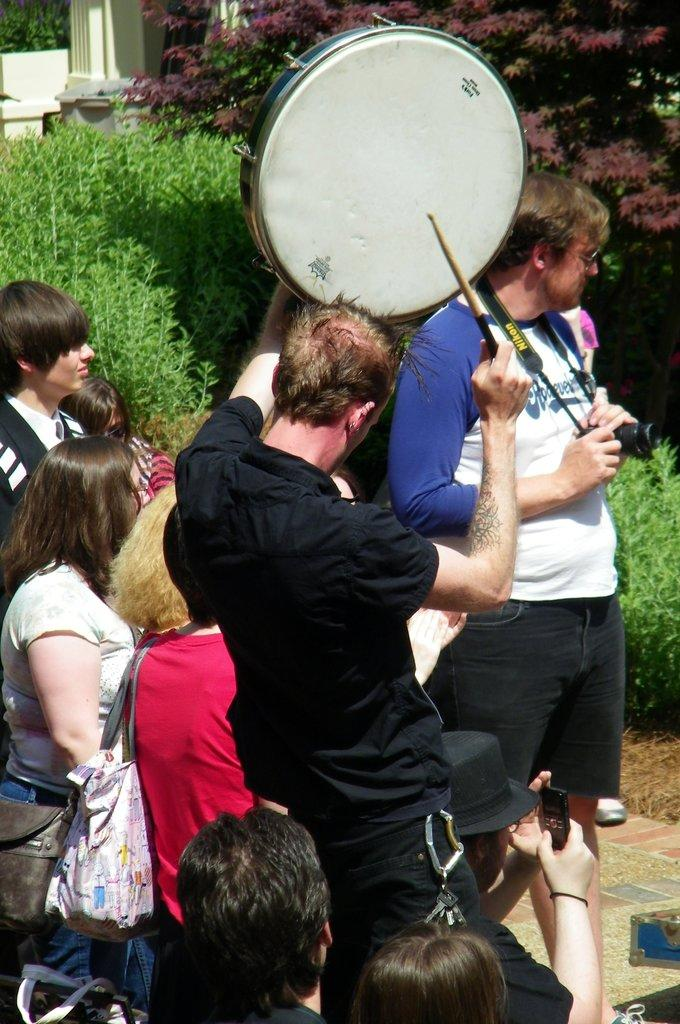What is the main activity being performed by the man in the image? The man is playing drums in the image. What is the other man holding in the image? The other man is holding a camera in the image. What unusual position are some people in the image? There are people standing on their backs in the image. What type of vegetation can be seen in the image? There are plants visible in the image. How does the man playing drums kick the temper of the plants in the image? There is no mention of the man playing drums kicking the temper of the plants in the image, nor is there any indication that the plants have a temper. 